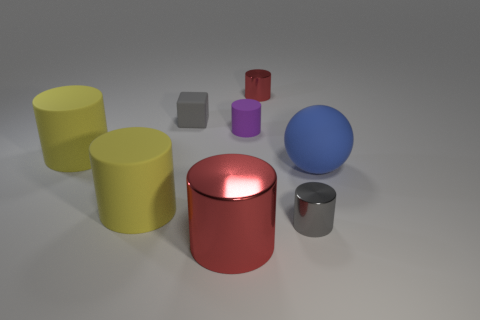What number of tiny cylinders are in front of the small gray thing that is right of the tiny cylinder that is behind the cube?
Your answer should be very brief. 0. Is there anything else that is the same color as the large metal object?
Provide a succinct answer. Yes. How many matte objects are both on the right side of the large shiny thing and behind the big sphere?
Your response must be concise. 1. Do the red thing that is in front of the large ball and the metal thing behind the rubber sphere have the same size?
Make the answer very short. No. What number of things are either gray objects that are behind the gray metal cylinder or tiny gray things?
Give a very brief answer. 2. What is the material of the red object behind the rubber ball?
Ensure brevity in your answer.  Metal. What is the tiny gray cylinder made of?
Give a very brief answer. Metal. What material is the red cylinder that is right of the big thing that is in front of the tiny cylinder that is in front of the large blue matte thing?
Offer a very short reply. Metal. Are there any other things that have the same material as the purple thing?
Provide a succinct answer. Yes. Do the blue rubber sphere and the red metallic thing in front of the purple cylinder have the same size?
Offer a terse response. Yes. 